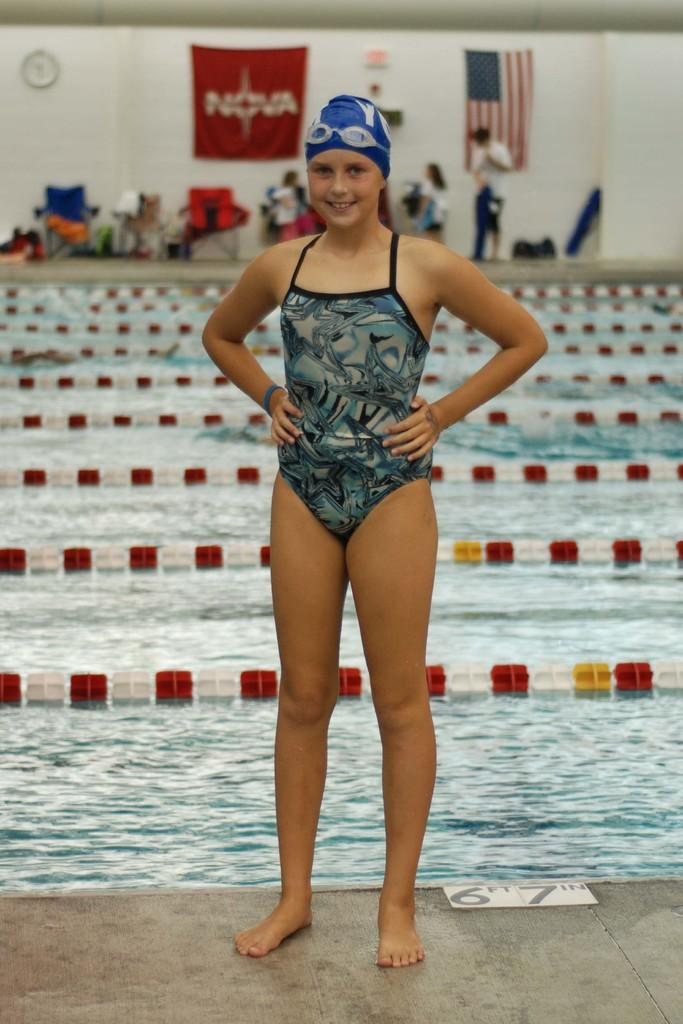Who is the main subject in the image? There is a girl in the image. What is the girl's expression in the image? The girl is smiling in the image. Where is the girl standing in the image? The girl is standing on the floor in the image. What can be seen in the background of the image? There is a swimming pool, a flag, chairs, and people visible in the background. What type of stamp can be seen on the girl's forehead in the image? There is no stamp visible on the girl's forehead in the image. 